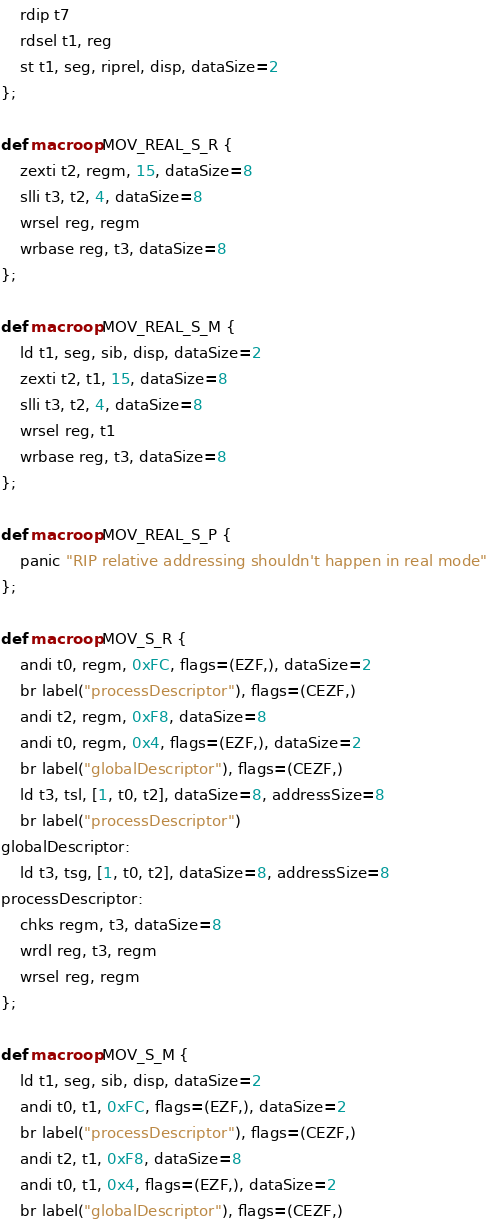<code> <loc_0><loc_0><loc_500><loc_500><_Python_>    rdip t7
    rdsel t1, reg
    st t1, seg, riprel, disp, dataSize=2
};

def macroop MOV_REAL_S_R {
    zexti t2, regm, 15, dataSize=8
    slli t3, t2, 4, dataSize=8
    wrsel reg, regm
    wrbase reg, t3, dataSize=8
};

def macroop MOV_REAL_S_M {
    ld t1, seg, sib, disp, dataSize=2
    zexti t2, t1, 15, dataSize=8
    slli t3, t2, 4, dataSize=8
    wrsel reg, t1
    wrbase reg, t3, dataSize=8
};

def macroop MOV_REAL_S_P {
    panic "RIP relative addressing shouldn't happen in real mode"
};

def macroop MOV_S_R {
    andi t0, regm, 0xFC, flags=(EZF,), dataSize=2
    br label("processDescriptor"), flags=(CEZF,)
    andi t2, regm, 0xF8, dataSize=8
    andi t0, regm, 0x4, flags=(EZF,), dataSize=2
    br label("globalDescriptor"), flags=(CEZF,)
    ld t3, tsl, [1, t0, t2], dataSize=8, addressSize=8
    br label("processDescriptor")
globalDescriptor:
    ld t3, tsg, [1, t0, t2], dataSize=8, addressSize=8
processDescriptor:
    chks regm, t3, dataSize=8
    wrdl reg, t3, regm
    wrsel reg, regm
};

def macroop MOV_S_M {
    ld t1, seg, sib, disp, dataSize=2
    andi t0, t1, 0xFC, flags=(EZF,), dataSize=2
    br label("processDescriptor"), flags=(CEZF,)
    andi t2, t1, 0xF8, dataSize=8
    andi t0, t1, 0x4, flags=(EZF,), dataSize=2
    br label("globalDescriptor"), flags=(CEZF,)</code> 